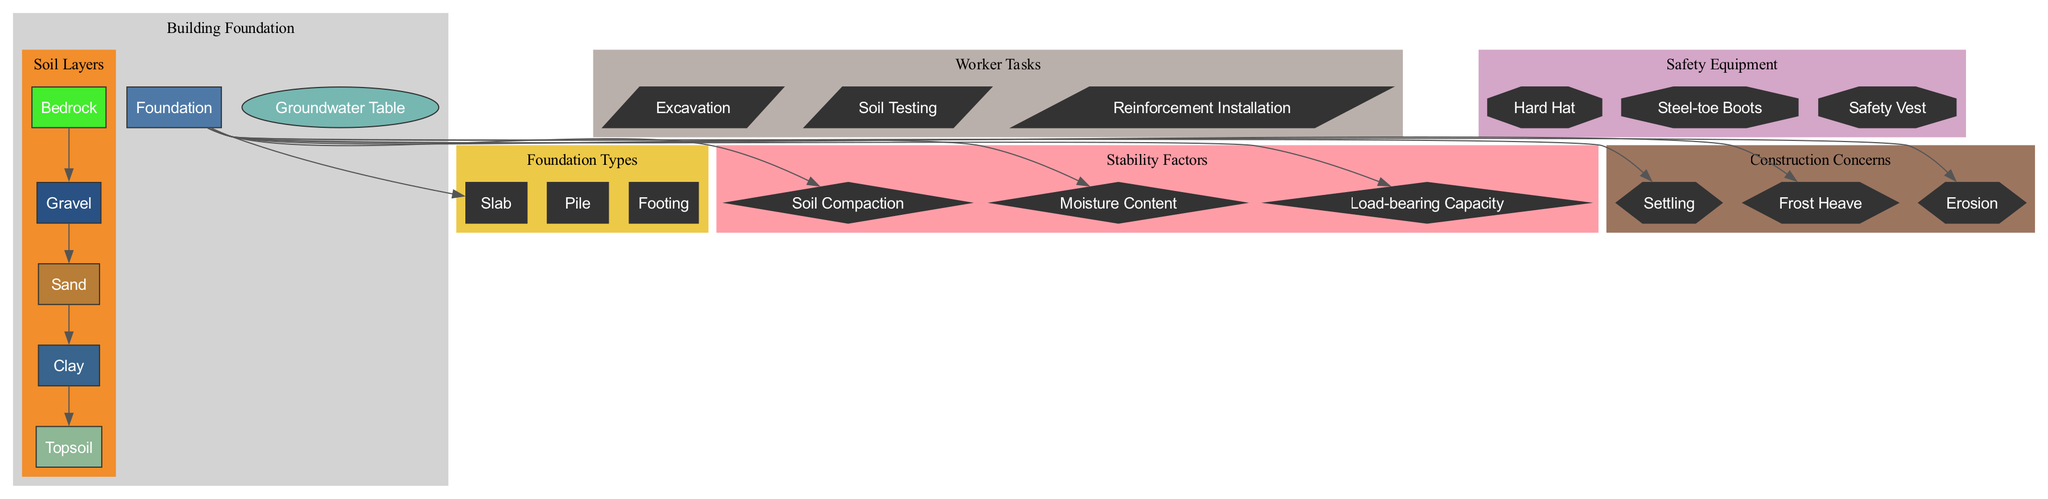What are the main components illustrated in the diagram? The diagram shows three main components: Foundation, Soil Layers, and Groundwater Table. This is evident from the labeled sections in the diagram that categorize these areas.
Answer: Foundation, Soil Layers, Groundwater Table How many soil layers are depicted in the diagram? The diagram lists five distinct soil layers: Topsoil, Clay, Sand, Gravel, and Bedrock. Counting these labels shows that there are five soil layers.
Answer: Five What is the type of foundation closest to the groundwater table? In the diagram, the Foundation is shown above the groundwater table, which is illustrated as an ellipse below the soil layers. Therefore, it's a Slab foundation type typically used in conditions with high groundwater.
Answer: Slab Which stability factor is related to the load-bearing capacity? The load-bearing capacity is directly mentioned as one of the stability factors in the diagram, which indicates that it is a critical aspect of a building's foundation stability.
Answer: Load-bearing Capacity What are the construction concerns related to soil layers? The concerns listed in the diagram that relate to the soil layers include Settling, Frost Heave, and Erosion. These are all indicated as potential issues that can arise due to the soil's characteristics and condition.
Answer: Settling, Frost Heave, Erosion Which task would a worker perform when preparing the foundation? The diagram shows Excavation, Soil Testing, and Reinforcement Installation as tasks. Among these, Excavation is typically the first task done as it involves removing soil to prepare for foundation work.
Answer: Excavation What type of equipment should workers wear for safety? The diagram lists three types of safety equipment: Hard Hat, Steel-toe Boots, and Safety Vest, indicating the necessary protective gear workers should use on a construction site.
Answer: Hard Hat, Steel-toe Boots, Safety Vest Which soil layer is the topmost in the construction diagram? The topsoil is presented as the highest layer in the soil section of the diagram. When visually inspecting the layers from top to bottom, it is clearly indicated as the first layer.
Answer: Topsoil What factors could affect the stability of the foundation? The stability factors include Soil Compaction, Moisture Content, and Load-bearing Capacity, which are illustrated as crucial aspects that affect foundation stability in the diagram.
Answer: Soil Compaction, Moisture Content, Load-bearing Capacity 